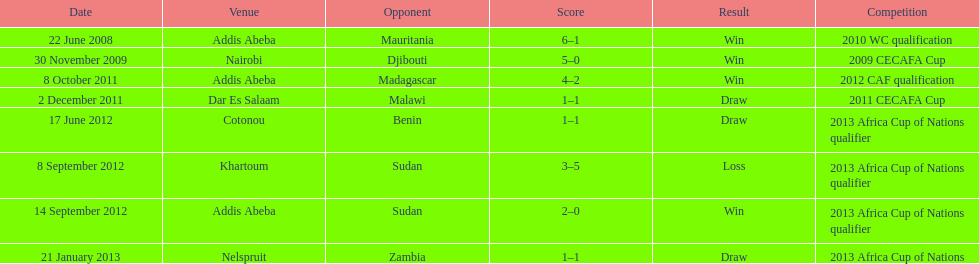Over how many years does this table cover extend? 5. 